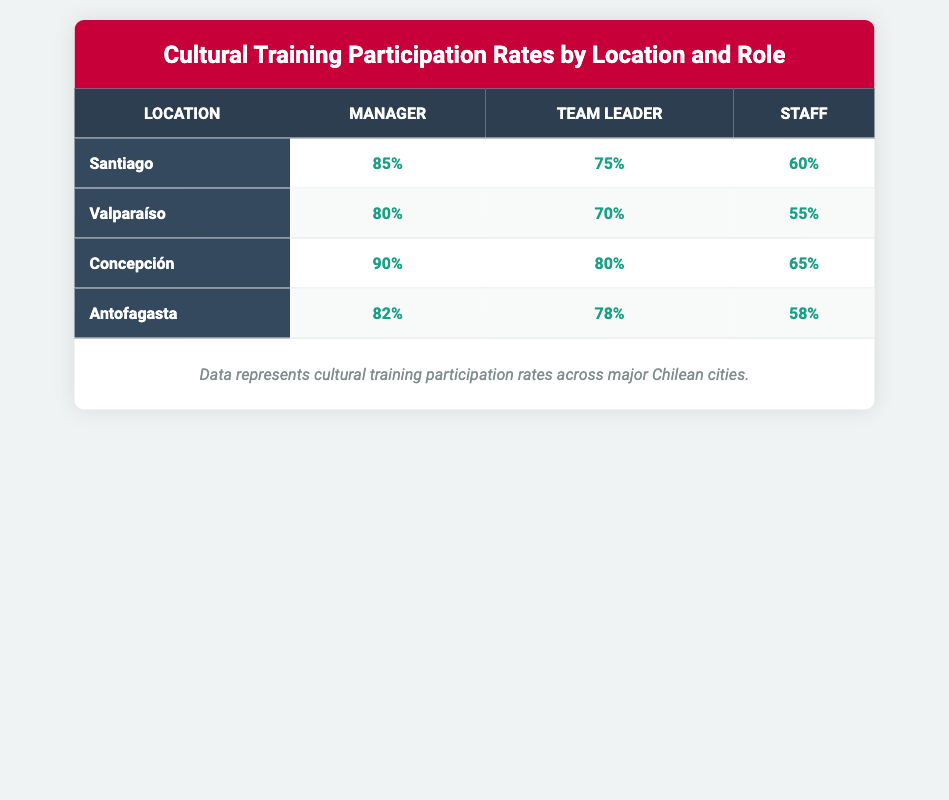What is the highest participation rate for Managers? The table shows that the highest participation rate for Managers is 90%, which is recorded in Concepción.
Answer: 90% What is the participation rate for Staff in Valparaíso? In the table, the participation rate for Staff in Valparaíso is listed as 55%.
Answer: 55% Which location has the lowest participation rate for Team Leaders? To determine this, we compare the participation rates for Team Leaders across all locations. Valparaíso has the lowest rate at 70%.
Answer: 70% What is the average participation rate for Staff across all locations? To find the average, we add the participation rates for Staff: 60 (Santiago) + 55 (Valparaíso) + 65 (Concepción) + 58 (Antofagasta) = 238. There are four locations, so the average is 238 / 4 = 59.5.
Answer: 59.5 Is the participation rate for Managers in Antofagasta higher than that in Valparaíso? The participation rate for Managers in Antofagasta is 82%, while in Valparaíso it is 80%. Since 82% is greater than 80%, the statement is true.
Answer: Yes Which role has the highest participation rate in Santiago? The table indicates that among the roles in Santiago, the Manager role has the highest participation rate, which is 85%.
Answer: Manager How much higher is the participation rate for Team Leaders in Concepción compared to those in Antofagasta? In Concepción, the participation rate for Team Leaders is 80%, and in Antofagasta it is 78%. The difference is calculated as 80 - 78 = 2%.
Answer: 2% Which location has the best overall participation rates across all roles? By looking at the participation rates for all roles, Concepción has the highest rates: Manager 90%, Team Leader 80%, and Staff 65%. The overall average is (90 + 80 + 65) / 3 = 78.33%, which is the highest when compared to other locations.
Answer: Concepción 